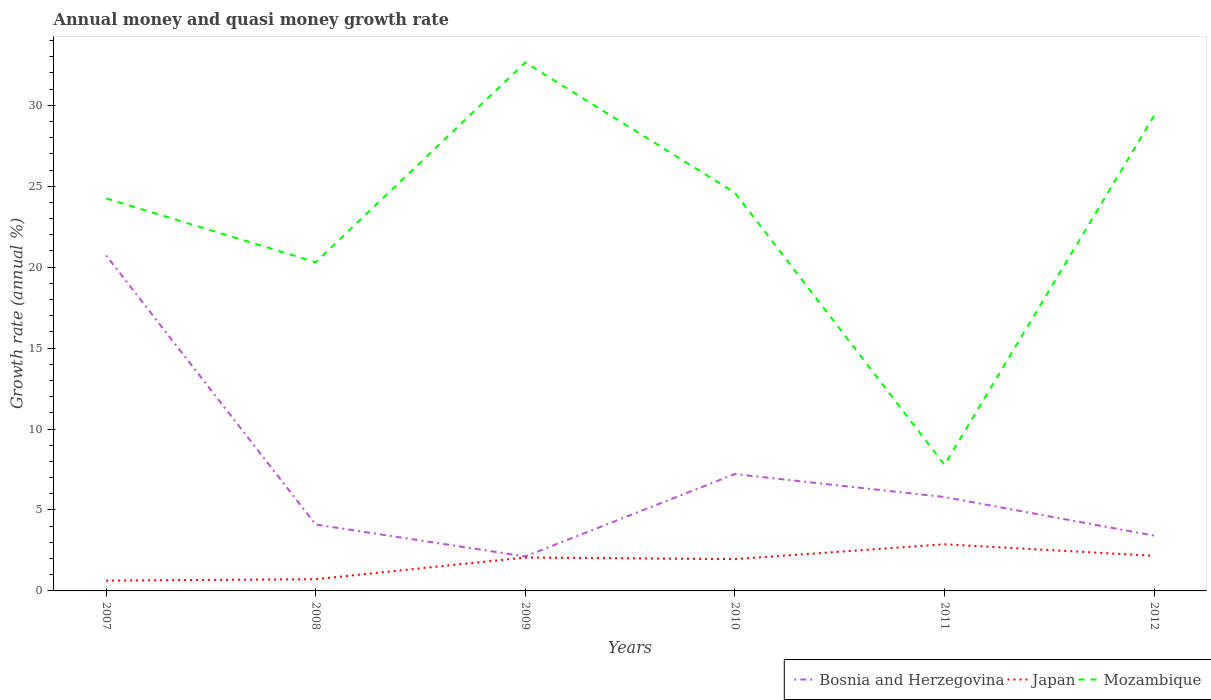Does the line corresponding to Japan intersect with the line corresponding to Mozambique?
Offer a very short reply. No. Is the number of lines equal to the number of legend labels?
Your answer should be compact. Yes. Across all years, what is the maximum growth rate in Bosnia and Herzegovina?
Your answer should be very brief. 2.13. In which year was the growth rate in Mozambique maximum?
Your answer should be compact. 2011. What is the total growth rate in Mozambique in the graph?
Provide a short and direct response. -21.57. What is the difference between the highest and the second highest growth rate in Bosnia and Herzegovina?
Provide a succinct answer. 18.59. How many lines are there?
Your response must be concise. 3. How many years are there in the graph?
Ensure brevity in your answer.  6. Does the graph contain any zero values?
Offer a terse response. No. How many legend labels are there?
Provide a succinct answer. 3. How are the legend labels stacked?
Your answer should be very brief. Horizontal. What is the title of the graph?
Ensure brevity in your answer.  Annual money and quasi money growth rate. What is the label or title of the Y-axis?
Make the answer very short. Growth rate (annual %). What is the Growth rate (annual %) in Bosnia and Herzegovina in 2007?
Ensure brevity in your answer.  20.72. What is the Growth rate (annual %) in Japan in 2007?
Offer a terse response. 0.63. What is the Growth rate (annual %) in Mozambique in 2007?
Give a very brief answer. 24.25. What is the Growth rate (annual %) in Bosnia and Herzegovina in 2008?
Give a very brief answer. 4.1. What is the Growth rate (annual %) of Japan in 2008?
Your response must be concise. 0.73. What is the Growth rate (annual %) of Mozambique in 2008?
Keep it short and to the point. 20.3. What is the Growth rate (annual %) of Bosnia and Herzegovina in 2009?
Make the answer very short. 2.13. What is the Growth rate (annual %) of Japan in 2009?
Your answer should be very brief. 2.06. What is the Growth rate (annual %) of Mozambique in 2009?
Give a very brief answer. 32.64. What is the Growth rate (annual %) of Bosnia and Herzegovina in 2010?
Give a very brief answer. 7.22. What is the Growth rate (annual %) of Japan in 2010?
Provide a short and direct response. 1.97. What is the Growth rate (annual %) of Mozambique in 2010?
Keep it short and to the point. 24.6. What is the Growth rate (annual %) in Bosnia and Herzegovina in 2011?
Offer a terse response. 5.8. What is the Growth rate (annual %) of Japan in 2011?
Offer a terse response. 2.88. What is the Growth rate (annual %) of Mozambique in 2011?
Your answer should be very brief. 7.79. What is the Growth rate (annual %) of Bosnia and Herzegovina in 2012?
Ensure brevity in your answer.  3.41. What is the Growth rate (annual %) of Japan in 2012?
Offer a very short reply. 2.17. What is the Growth rate (annual %) in Mozambique in 2012?
Provide a short and direct response. 29.35. Across all years, what is the maximum Growth rate (annual %) of Bosnia and Herzegovina?
Provide a short and direct response. 20.72. Across all years, what is the maximum Growth rate (annual %) in Japan?
Your answer should be compact. 2.88. Across all years, what is the maximum Growth rate (annual %) in Mozambique?
Your response must be concise. 32.64. Across all years, what is the minimum Growth rate (annual %) in Bosnia and Herzegovina?
Keep it short and to the point. 2.13. Across all years, what is the minimum Growth rate (annual %) in Japan?
Offer a terse response. 0.63. Across all years, what is the minimum Growth rate (annual %) in Mozambique?
Your response must be concise. 7.79. What is the total Growth rate (annual %) in Bosnia and Herzegovina in the graph?
Your response must be concise. 43.39. What is the total Growth rate (annual %) in Japan in the graph?
Provide a succinct answer. 10.44. What is the total Growth rate (annual %) in Mozambique in the graph?
Provide a succinct answer. 138.93. What is the difference between the Growth rate (annual %) in Bosnia and Herzegovina in 2007 and that in 2008?
Offer a very short reply. 16.62. What is the difference between the Growth rate (annual %) in Japan in 2007 and that in 2008?
Your response must be concise. -0.09. What is the difference between the Growth rate (annual %) in Mozambique in 2007 and that in 2008?
Keep it short and to the point. 3.94. What is the difference between the Growth rate (annual %) in Bosnia and Herzegovina in 2007 and that in 2009?
Your answer should be very brief. 18.59. What is the difference between the Growth rate (annual %) of Japan in 2007 and that in 2009?
Your answer should be very brief. -1.43. What is the difference between the Growth rate (annual %) of Mozambique in 2007 and that in 2009?
Provide a succinct answer. -8.4. What is the difference between the Growth rate (annual %) of Bosnia and Herzegovina in 2007 and that in 2010?
Your response must be concise. 13.51. What is the difference between the Growth rate (annual %) in Japan in 2007 and that in 2010?
Provide a succinct answer. -1.33. What is the difference between the Growth rate (annual %) in Mozambique in 2007 and that in 2010?
Provide a succinct answer. -0.35. What is the difference between the Growth rate (annual %) of Bosnia and Herzegovina in 2007 and that in 2011?
Give a very brief answer. 14.93. What is the difference between the Growth rate (annual %) in Japan in 2007 and that in 2011?
Keep it short and to the point. -2.25. What is the difference between the Growth rate (annual %) in Mozambique in 2007 and that in 2011?
Provide a short and direct response. 16.46. What is the difference between the Growth rate (annual %) in Bosnia and Herzegovina in 2007 and that in 2012?
Offer a very short reply. 17.31. What is the difference between the Growth rate (annual %) in Japan in 2007 and that in 2012?
Provide a short and direct response. -1.53. What is the difference between the Growth rate (annual %) in Mozambique in 2007 and that in 2012?
Keep it short and to the point. -5.11. What is the difference between the Growth rate (annual %) of Bosnia and Herzegovina in 2008 and that in 2009?
Your answer should be very brief. 1.97. What is the difference between the Growth rate (annual %) of Japan in 2008 and that in 2009?
Make the answer very short. -1.34. What is the difference between the Growth rate (annual %) of Mozambique in 2008 and that in 2009?
Keep it short and to the point. -12.34. What is the difference between the Growth rate (annual %) of Bosnia and Herzegovina in 2008 and that in 2010?
Your answer should be compact. -3.12. What is the difference between the Growth rate (annual %) of Japan in 2008 and that in 2010?
Your answer should be compact. -1.24. What is the difference between the Growth rate (annual %) of Mozambique in 2008 and that in 2010?
Make the answer very short. -4.29. What is the difference between the Growth rate (annual %) of Bosnia and Herzegovina in 2008 and that in 2011?
Your answer should be very brief. -1.7. What is the difference between the Growth rate (annual %) in Japan in 2008 and that in 2011?
Your answer should be very brief. -2.15. What is the difference between the Growth rate (annual %) in Mozambique in 2008 and that in 2011?
Keep it short and to the point. 12.52. What is the difference between the Growth rate (annual %) in Bosnia and Herzegovina in 2008 and that in 2012?
Ensure brevity in your answer.  0.69. What is the difference between the Growth rate (annual %) in Japan in 2008 and that in 2012?
Keep it short and to the point. -1.44. What is the difference between the Growth rate (annual %) in Mozambique in 2008 and that in 2012?
Keep it short and to the point. -9.05. What is the difference between the Growth rate (annual %) of Bosnia and Herzegovina in 2009 and that in 2010?
Offer a very short reply. -5.09. What is the difference between the Growth rate (annual %) of Japan in 2009 and that in 2010?
Your response must be concise. 0.1. What is the difference between the Growth rate (annual %) of Mozambique in 2009 and that in 2010?
Your answer should be compact. 8.05. What is the difference between the Growth rate (annual %) in Bosnia and Herzegovina in 2009 and that in 2011?
Your answer should be very brief. -3.67. What is the difference between the Growth rate (annual %) of Japan in 2009 and that in 2011?
Ensure brevity in your answer.  -0.82. What is the difference between the Growth rate (annual %) of Mozambique in 2009 and that in 2011?
Ensure brevity in your answer.  24.86. What is the difference between the Growth rate (annual %) of Bosnia and Herzegovina in 2009 and that in 2012?
Provide a succinct answer. -1.28. What is the difference between the Growth rate (annual %) in Japan in 2009 and that in 2012?
Provide a succinct answer. -0.1. What is the difference between the Growth rate (annual %) in Mozambique in 2009 and that in 2012?
Your response must be concise. 3.29. What is the difference between the Growth rate (annual %) of Bosnia and Herzegovina in 2010 and that in 2011?
Your answer should be very brief. 1.42. What is the difference between the Growth rate (annual %) in Japan in 2010 and that in 2011?
Offer a very short reply. -0.92. What is the difference between the Growth rate (annual %) in Mozambique in 2010 and that in 2011?
Provide a succinct answer. 16.81. What is the difference between the Growth rate (annual %) in Bosnia and Herzegovina in 2010 and that in 2012?
Provide a short and direct response. 3.8. What is the difference between the Growth rate (annual %) of Japan in 2010 and that in 2012?
Your response must be concise. -0.2. What is the difference between the Growth rate (annual %) of Mozambique in 2010 and that in 2012?
Your answer should be very brief. -4.76. What is the difference between the Growth rate (annual %) of Bosnia and Herzegovina in 2011 and that in 2012?
Ensure brevity in your answer.  2.38. What is the difference between the Growth rate (annual %) of Japan in 2011 and that in 2012?
Your answer should be compact. 0.71. What is the difference between the Growth rate (annual %) in Mozambique in 2011 and that in 2012?
Your answer should be very brief. -21.57. What is the difference between the Growth rate (annual %) of Bosnia and Herzegovina in 2007 and the Growth rate (annual %) of Japan in 2008?
Give a very brief answer. 20. What is the difference between the Growth rate (annual %) in Bosnia and Herzegovina in 2007 and the Growth rate (annual %) in Mozambique in 2008?
Ensure brevity in your answer.  0.42. What is the difference between the Growth rate (annual %) of Japan in 2007 and the Growth rate (annual %) of Mozambique in 2008?
Offer a very short reply. -19.67. What is the difference between the Growth rate (annual %) in Bosnia and Herzegovina in 2007 and the Growth rate (annual %) in Japan in 2009?
Offer a very short reply. 18.66. What is the difference between the Growth rate (annual %) in Bosnia and Herzegovina in 2007 and the Growth rate (annual %) in Mozambique in 2009?
Your answer should be compact. -11.92. What is the difference between the Growth rate (annual %) of Japan in 2007 and the Growth rate (annual %) of Mozambique in 2009?
Your answer should be very brief. -32.01. What is the difference between the Growth rate (annual %) of Bosnia and Herzegovina in 2007 and the Growth rate (annual %) of Japan in 2010?
Offer a very short reply. 18.76. What is the difference between the Growth rate (annual %) of Bosnia and Herzegovina in 2007 and the Growth rate (annual %) of Mozambique in 2010?
Your response must be concise. -3.87. What is the difference between the Growth rate (annual %) in Japan in 2007 and the Growth rate (annual %) in Mozambique in 2010?
Provide a short and direct response. -23.96. What is the difference between the Growth rate (annual %) of Bosnia and Herzegovina in 2007 and the Growth rate (annual %) of Japan in 2011?
Provide a short and direct response. 17.84. What is the difference between the Growth rate (annual %) in Bosnia and Herzegovina in 2007 and the Growth rate (annual %) in Mozambique in 2011?
Keep it short and to the point. 12.94. What is the difference between the Growth rate (annual %) in Japan in 2007 and the Growth rate (annual %) in Mozambique in 2011?
Offer a terse response. -7.15. What is the difference between the Growth rate (annual %) of Bosnia and Herzegovina in 2007 and the Growth rate (annual %) of Japan in 2012?
Your answer should be compact. 18.56. What is the difference between the Growth rate (annual %) of Bosnia and Herzegovina in 2007 and the Growth rate (annual %) of Mozambique in 2012?
Provide a succinct answer. -8.63. What is the difference between the Growth rate (annual %) of Japan in 2007 and the Growth rate (annual %) of Mozambique in 2012?
Your response must be concise. -28.72. What is the difference between the Growth rate (annual %) in Bosnia and Herzegovina in 2008 and the Growth rate (annual %) in Japan in 2009?
Your answer should be very brief. 2.04. What is the difference between the Growth rate (annual %) in Bosnia and Herzegovina in 2008 and the Growth rate (annual %) in Mozambique in 2009?
Your answer should be very brief. -28.54. What is the difference between the Growth rate (annual %) of Japan in 2008 and the Growth rate (annual %) of Mozambique in 2009?
Your response must be concise. -31.92. What is the difference between the Growth rate (annual %) of Bosnia and Herzegovina in 2008 and the Growth rate (annual %) of Japan in 2010?
Ensure brevity in your answer.  2.13. What is the difference between the Growth rate (annual %) in Bosnia and Herzegovina in 2008 and the Growth rate (annual %) in Mozambique in 2010?
Give a very brief answer. -20.5. What is the difference between the Growth rate (annual %) of Japan in 2008 and the Growth rate (annual %) of Mozambique in 2010?
Keep it short and to the point. -23.87. What is the difference between the Growth rate (annual %) of Bosnia and Herzegovina in 2008 and the Growth rate (annual %) of Japan in 2011?
Your response must be concise. 1.22. What is the difference between the Growth rate (annual %) of Bosnia and Herzegovina in 2008 and the Growth rate (annual %) of Mozambique in 2011?
Keep it short and to the point. -3.69. What is the difference between the Growth rate (annual %) of Japan in 2008 and the Growth rate (annual %) of Mozambique in 2011?
Your answer should be very brief. -7.06. What is the difference between the Growth rate (annual %) of Bosnia and Herzegovina in 2008 and the Growth rate (annual %) of Japan in 2012?
Keep it short and to the point. 1.93. What is the difference between the Growth rate (annual %) in Bosnia and Herzegovina in 2008 and the Growth rate (annual %) in Mozambique in 2012?
Provide a succinct answer. -25.25. What is the difference between the Growth rate (annual %) of Japan in 2008 and the Growth rate (annual %) of Mozambique in 2012?
Give a very brief answer. -28.63. What is the difference between the Growth rate (annual %) of Bosnia and Herzegovina in 2009 and the Growth rate (annual %) of Japan in 2010?
Provide a succinct answer. 0.17. What is the difference between the Growth rate (annual %) in Bosnia and Herzegovina in 2009 and the Growth rate (annual %) in Mozambique in 2010?
Provide a short and direct response. -22.46. What is the difference between the Growth rate (annual %) of Japan in 2009 and the Growth rate (annual %) of Mozambique in 2010?
Keep it short and to the point. -22.53. What is the difference between the Growth rate (annual %) of Bosnia and Herzegovina in 2009 and the Growth rate (annual %) of Japan in 2011?
Your answer should be compact. -0.75. What is the difference between the Growth rate (annual %) in Bosnia and Herzegovina in 2009 and the Growth rate (annual %) in Mozambique in 2011?
Make the answer very short. -5.66. What is the difference between the Growth rate (annual %) of Japan in 2009 and the Growth rate (annual %) of Mozambique in 2011?
Give a very brief answer. -5.72. What is the difference between the Growth rate (annual %) in Bosnia and Herzegovina in 2009 and the Growth rate (annual %) in Japan in 2012?
Offer a very short reply. -0.04. What is the difference between the Growth rate (annual %) of Bosnia and Herzegovina in 2009 and the Growth rate (annual %) of Mozambique in 2012?
Keep it short and to the point. -27.22. What is the difference between the Growth rate (annual %) of Japan in 2009 and the Growth rate (annual %) of Mozambique in 2012?
Provide a short and direct response. -27.29. What is the difference between the Growth rate (annual %) in Bosnia and Herzegovina in 2010 and the Growth rate (annual %) in Japan in 2011?
Keep it short and to the point. 4.34. What is the difference between the Growth rate (annual %) in Bosnia and Herzegovina in 2010 and the Growth rate (annual %) in Mozambique in 2011?
Keep it short and to the point. -0.57. What is the difference between the Growth rate (annual %) of Japan in 2010 and the Growth rate (annual %) of Mozambique in 2011?
Make the answer very short. -5.82. What is the difference between the Growth rate (annual %) of Bosnia and Herzegovina in 2010 and the Growth rate (annual %) of Japan in 2012?
Keep it short and to the point. 5.05. What is the difference between the Growth rate (annual %) in Bosnia and Herzegovina in 2010 and the Growth rate (annual %) in Mozambique in 2012?
Your response must be concise. -22.13. What is the difference between the Growth rate (annual %) of Japan in 2010 and the Growth rate (annual %) of Mozambique in 2012?
Keep it short and to the point. -27.39. What is the difference between the Growth rate (annual %) in Bosnia and Herzegovina in 2011 and the Growth rate (annual %) in Japan in 2012?
Give a very brief answer. 3.63. What is the difference between the Growth rate (annual %) of Bosnia and Herzegovina in 2011 and the Growth rate (annual %) of Mozambique in 2012?
Provide a succinct answer. -23.55. What is the difference between the Growth rate (annual %) in Japan in 2011 and the Growth rate (annual %) in Mozambique in 2012?
Your answer should be compact. -26.47. What is the average Growth rate (annual %) in Bosnia and Herzegovina per year?
Provide a short and direct response. 7.23. What is the average Growth rate (annual %) of Japan per year?
Make the answer very short. 1.74. What is the average Growth rate (annual %) in Mozambique per year?
Keep it short and to the point. 23.16. In the year 2007, what is the difference between the Growth rate (annual %) in Bosnia and Herzegovina and Growth rate (annual %) in Japan?
Ensure brevity in your answer.  20.09. In the year 2007, what is the difference between the Growth rate (annual %) of Bosnia and Herzegovina and Growth rate (annual %) of Mozambique?
Your answer should be very brief. -3.52. In the year 2007, what is the difference between the Growth rate (annual %) in Japan and Growth rate (annual %) in Mozambique?
Provide a succinct answer. -23.61. In the year 2008, what is the difference between the Growth rate (annual %) in Bosnia and Herzegovina and Growth rate (annual %) in Japan?
Your response must be concise. 3.37. In the year 2008, what is the difference between the Growth rate (annual %) of Bosnia and Herzegovina and Growth rate (annual %) of Mozambique?
Your response must be concise. -16.2. In the year 2008, what is the difference between the Growth rate (annual %) in Japan and Growth rate (annual %) in Mozambique?
Make the answer very short. -19.58. In the year 2009, what is the difference between the Growth rate (annual %) of Bosnia and Herzegovina and Growth rate (annual %) of Japan?
Offer a very short reply. 0.07. In the year 2009, what is the difference between the Growth rate (annual %) in Bosnia and Herzegovina and Growth rate (annual %) in Mozambique?
Your response must be concise. -30.51. In the year 2009, what is the difference between the Growth rate (annual %) of Japan and Growth rate (annual %) of Mozambique?
Keep it short and to the point. -30.58. In the year 2010, what is the difference between the Growth rate (annual %) of Bosnia and Herzegovina and Growth rate (annual %) of Japan?
Your answer should be very brief. 5.25. In the year 2010, what is the difference between the Growth rate (annual %) in Bosnia and Herzegovina and Growth rate (annual %) in Mozambique?
Provide a short and direct response. -17.38. In the year 2010, what is the difference between the Growth rate (annual %) of Japan and Growth rate (annual %) of Mozambique?
Your response must be concise. -22.63. In the year 2011, what is the difference between the Growth rate (annual %) in Bosnia and Herzegovina and Growth rate (annual %) in Japan?
Provide a short and direct response. 2.92. In the year 2011, what is the difference between the Growth rate (annual %) in Bosnia and Herzegovina and Growth rate (annual %) in Mozambique?
Ensure brevity in your answer.  -1.99. In the year 2011, what is the difference between the Growth rate (annual %) of Japan and Growth rate (annual %) of Mozambique?
Your answer should be compact. -4.91. In the year 2012, what is the difference between the Growth rate (annual %) of Bosnia and Herzegovina and Growth rate (annual %) of Japan?
Offer a terse response. 1.25. In the year 2012, what is the difference between the Growth rate (annual %) of Bosnia and Herzegovina and Growth rate (annual %) of Mozambique?
Provide a succinct answer. -25.94. In the year 2012, what is the difference between the Growth rate (annual %) in Japan and Growth rate (annual %) in Mozambique?
Provide a short and direct response. -27.19. What is the ratio of the Growth rate (annual %) of Bosnia and Herzegovina in 2007 to that in 2008?
Give a very brief answer. 5.05. What is the ratio of the Growth rate (annual %) of Japan in 2007 to that in 2008?
Provide a succinct answer. 0.87. What is the ratio of the Growth rate (annual %) of Mozambique in 2007 to that in 2008?
Give a very brief answer. 1.19. What is the ratio of the Growth rate (annual %) in Bosnia and Herzegovina in 2007 to that in 2009?
Your answer should be very brief. 9.72. What is the ratio of the Growth rate (annual %) in Japan in 2007 to that in 2009?
Offer a terse response. 0.31. What is the ratio of the Growth rate (annual %) in Mozambique in 2007 to that in 2009?
Give a very brief answer. 0.74. What is the ratio of the Growth rate (annual %) in Bosnia and Herzegovina in 2007 to that in 2010?
Your answer should be compact. 2.87. What is the ratio of the Growth rate (annual %) in Japan in 2007 to that in 2010?
Provide a short and direct response. 0.32. What is the ratio of the Growth rate (annual %) of Mozambique in 2007 to that in 2010?
Give a very brief answer. 0.99. What is the ratio of the Growth rate (annual %) in Bosnia and Herzegovina in 2007 to that in 2011?
Your response must be concise. 3.57. What is the ratio of the Growth rate (annual %) in Japan in 2007 to that in 2011?
Give a very brief answer. 0.22. What is the ratio of the Growth rate (annual %) of Mozambique in 2007 to that in 2011?
Make the answer very short. 3.11. What is the ratio of the Growth rate (annual %) of Bosnia and Herzegovina in 2007 to that in 2012?
Keep it short and to the point. 6.07. What is the ratio of the Growth rate (annual %) in Japan in 2007 to that in 2012?
Offer a very short reply. 0.29. What is the ratio of the Growth rate (annual %) of Mozambique in 2007 to that in 2012?
Your answer should be compact. 0.83. What is the ratio of the Growth rate (annual %) in Bosnia and Herzegovina in 2008 to that in 2009?
Offer a terse response. 1.92. What is the ratio of the Growth rate (annual %) in Japan in 2008 to that in 2009?
Offer a very short reply. 0.35. What is the ratio of the Growth rate (annual %) in Mozambique in 2008 to that in 2009?
Your answer should be very brief. 0.62. What is the ratio of the Growth rate (annual %) of Bosnia and Herzegovina in 2008 to that in 2010?
Keep it short and to the point. 0.57. What is the ratio of the Growth rate (annual %) of Japan in 2008 to that in 2010?
Offer a very short reply. 0.37. What is the ratio of the Growth rate (annual %) in Mozambique in 2008 to that in 2010?
Provide a succinct answer. 0.83. What is the ratio of the Growth rate (annual %) of Bosnia and Herzegovina in 2008 to that in 2011?
Offer a very short reply. 0.71. What is the ratio of the Growth rate (annual %) of Japan in 2008 to that in 2011?
Provide a succinct answer. 0.25. What is the ratio of the Growth rate (annual %) of Mozambique in 2008 to that in 2011?
Provide a short and direct response. 2.61. What is the ratio of the Growth rate (annual %) in Bosnia and Herzegovina in 2008 to that in 2012?
Ensure brevity in your answer.  1.2. What is the ratio of the Growth rate (annual %) in Japan in 2008 to that in 2012?
Keep it short and to the point. 0.33. What is the ratio of the Growth rate (annual %) in Mozambique in 2008 to that in 2012?
Make the answer very short. 0.69. What is the ratio of the Growth rate (annual %) in Bosnia and Herzegovina in 2009 to that in 2010?
Offer a terse response. 0.3. What is the ratio of the Growth rate (annual %) in Japan in 2009 to that in 2010?
Ensure brevity in your answer.  1.05. What is the ratio of the Growth rate (annual %) in Mozambique in 2009 to that in 2010?
Provide a short and direct response. 1.33. What is the ratio of the Growth rate (annual %) in Bosnia and Herzegovina in 2009 to that in 2011?
Offer a very short reply. 0.37. What is the ratio of the Growth rate (annual %) in Japan in 2009 to that in 2011?
Your response must be concise. 0.72. What is the ratio of the Growth rate (annual %) of Mozambique in 2009 to that in 2011?
Ensure brevity in your answer.  4.19. What is the ratio of the Growth rate (annual %) of Bosnia and Herzegovina in 2009 to that in 2012?
Provide a succinct answer. 0.62. What is the ratio of the Growth rate (annual %) of Japan in 2009 to that in 2012?
Provide a short and direct response. 0.95. What is the ratio of the Growth rate (annual %) in Mozambique in 2009 to that in 2012?
Keep it short and to the point. 1.11. What is the ratio of the Growth rate (annual %) of Bosnia and Herzegovina in 2010 to that in 2011?
Your answer should be compact. 1.25. What is the ratio of the Growth rate (annual %) in Japan in 2010 to that in 2011?
Your answer should be compact. 0.68. What is the ratio of the Growth rate (annual %) in Mozambique in 2010 to that in 2011?
Give a very brief answer. 3.16. What is the ratio of the Growth rate (annual %) in Bosnia and Herzegovina in 2010 to that in 2012?
Give a very brief answer. 2.11. What is the ratio of the Growth rate (annual %) in Japan in 2010 to that in 2012?
Make the answer very short. 0.91. What is the ratio of the Growth rate (annual %) in Mozambique in 2010 to that in 2012?
Keep it short and to the point. 0.84. What is the ratio of the Growth rate (annual %) of Bosnia and Herzegovina in 2011 to that in 2012?
Offer a terse response. 1.7. What is the ratio of the Growth rate (annual %) of Japan in 2011 to that in 2012?
Offer a very short reply. 1.33. What is the ratio of the Growth rate (annual %) in Mozambique in 2011 to that in 2012?
Your answer should be very brief. 0.27. What is the difference between the highest and the second highest Growth rate (annual %) in Bosnia and Herzegovina?
Your answer should be compact. 13.51. What is the difference between the highest and the second highest Growth rate (annual %) in Japan?
Your answer should be very brief. 0.71. What is the difference between the highest and the second highest Growth rate (annual %) in Mozambique?
Offer a terse response. 3.29. What is the difference between the highest and the lowest Growth rate (annual %) of Bosnia and Herzegovina?
Provide a succinct answer. 18.59. What is the difference between the highest and the lowest Growth rate (annual %) in Japan?
Keep it short and to the point. 2.25. What is the difference between the highest and the lowest Growth rate (annual %) in Mozambique?
Ensure brevity in your answer.  24.86. 